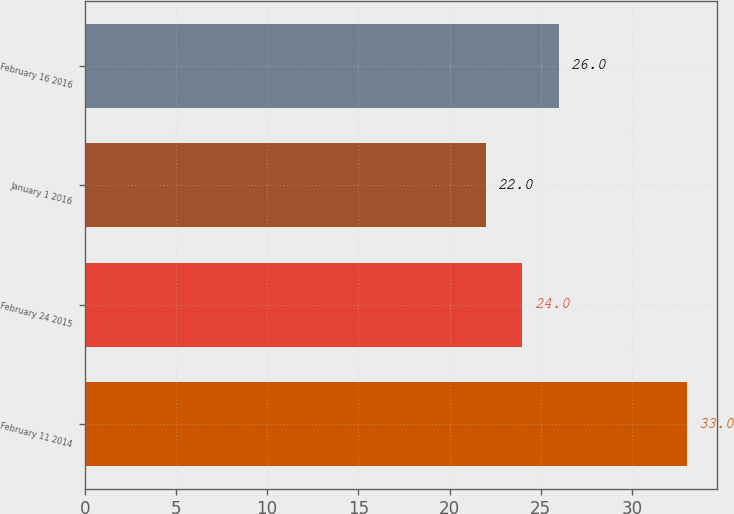<chart> <loc_0><loc_0><loc_500><loc_500><bar_chart><fcel>February 11 2014<fcel>February 24 2015<fcel>January 1 2016<fcel>February 16 2016<nl><fcel>33<fcel>24<fcel>22<fcel>26<nl></chart> 